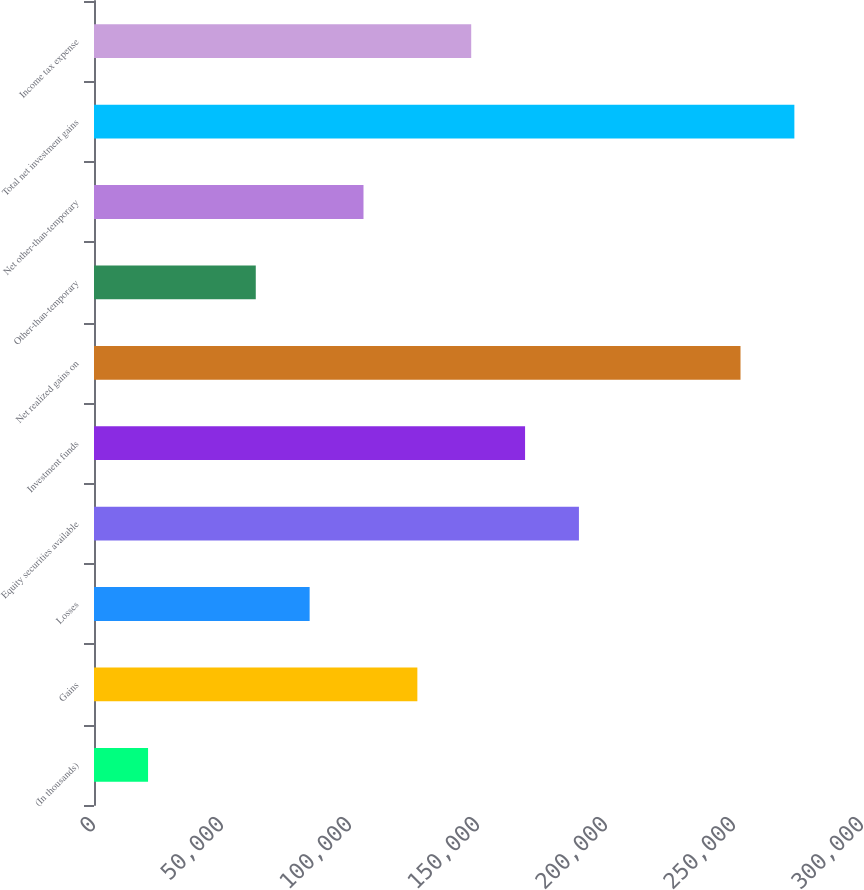Convert chart to OTSL. <chart><loc_0><loc_0><loc_500><loc_500><bar_chart><fcel>(In thousands)<fcel>Gains<fcel>Losses<fcel>Equity securities available<fcel>Investment funds<fcel>Net realized gains on<fcel>Other-than-temporary<fcel>Net other-than-temporary<fcel>Total net investment gains<fcel>Income tax expense<nl><fcel>21115.8<fcel>126310<fcel>84232.2<fcel>189426<fcel>168387<fcel>252543<fcel>63193.4<fcel>105271<fcel>273581<fcel>147349<nl></chart> 